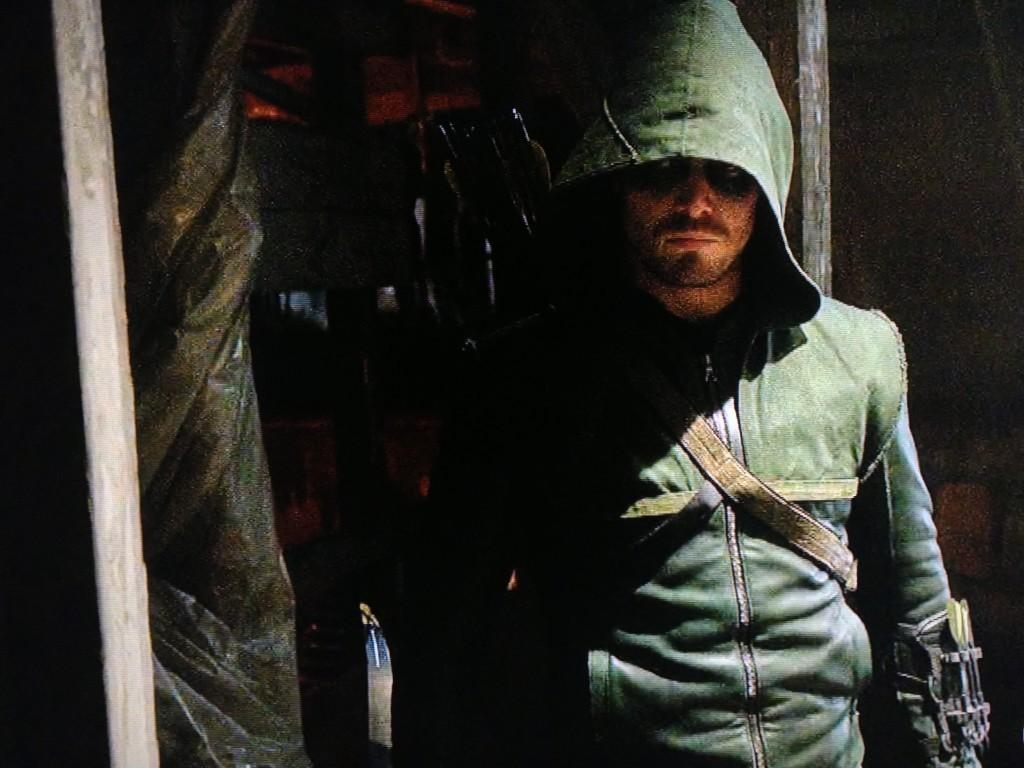Who or what is present in the image? There is a person in the image. What type of objects can be seen in the image? There are wooden poles and some other objects in the image. How would you describe the background of the image? The background of the image is dark. What type of vessel is being used to transport the bricks in the image? There is no vessel or bricks present in the image. How much lead can be seen in the image? There is no lead visible in the image. 